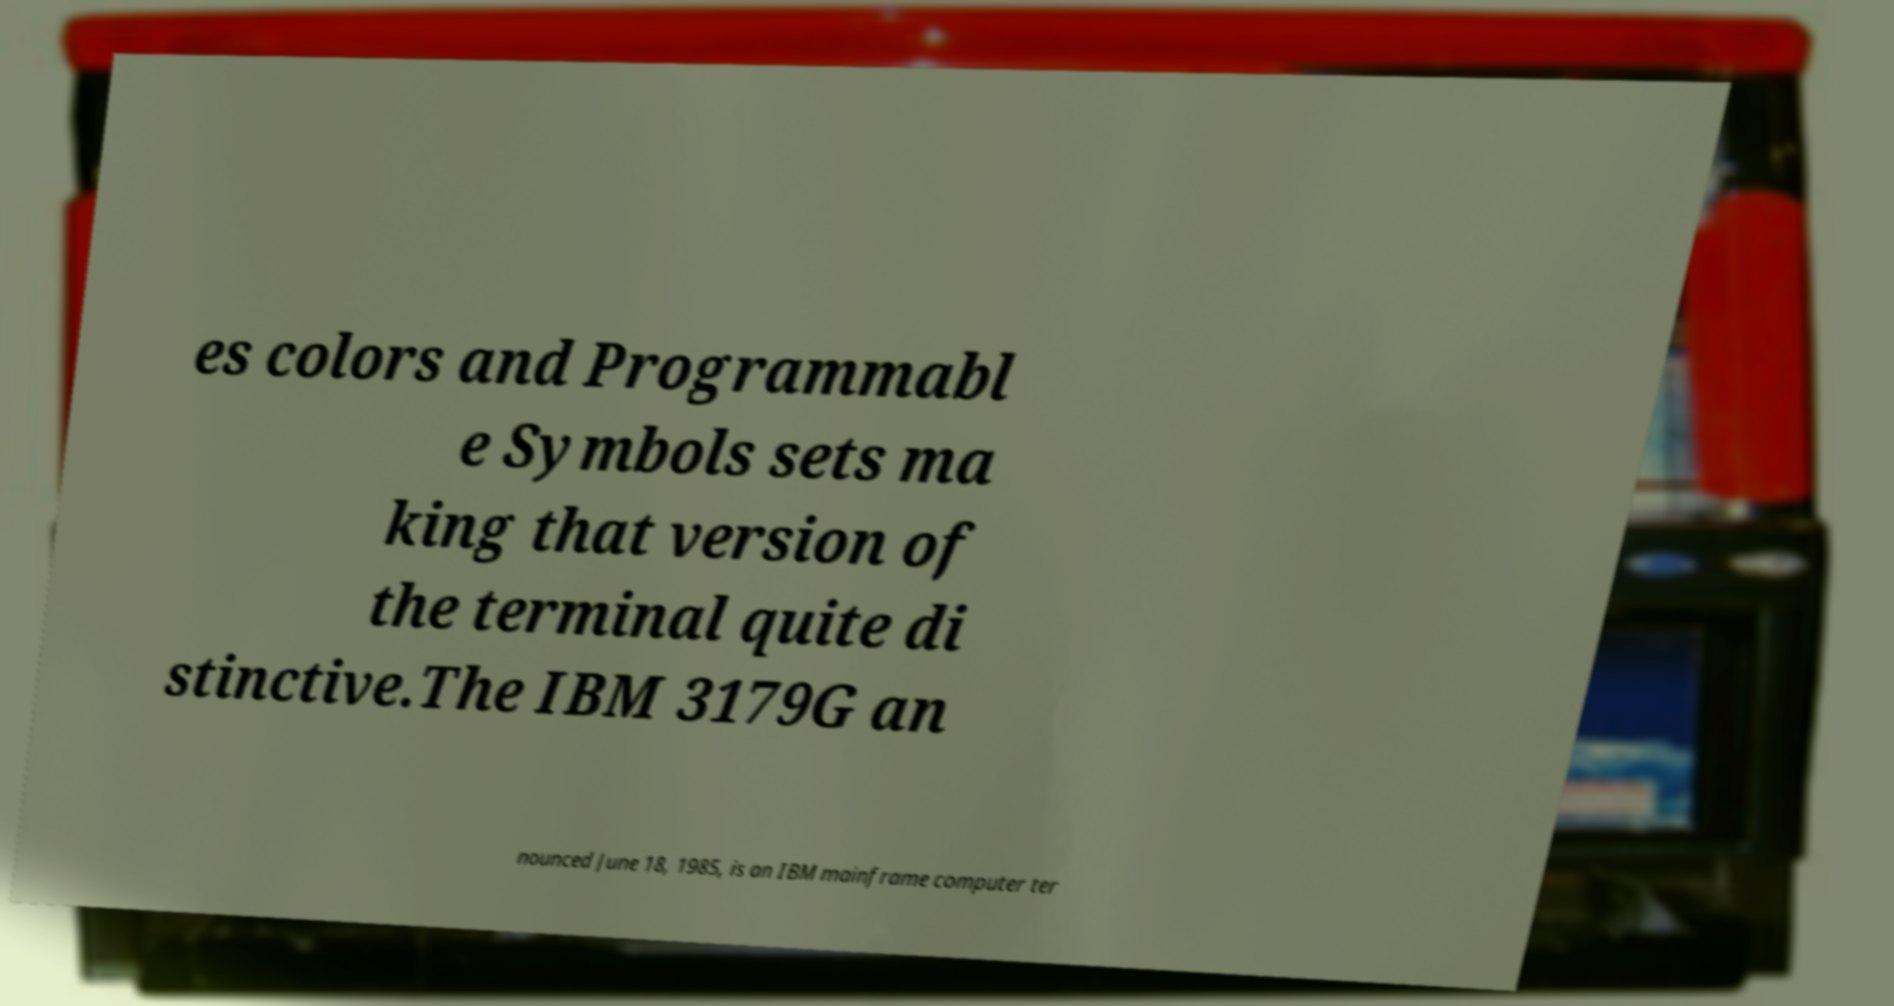What messages or text are displayed in this image? I need them in a readable, typed format. es colors and Programmabl e Symbols sets ma king that version of the terminal quite di stinctive.The IBM 3179G an nounced June 18, 1985, is an IBM mainframe computer ter 